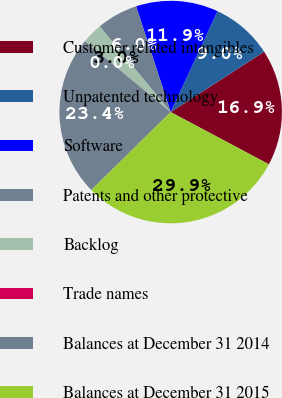<chart> <loc_0><loc_0><loc_500><loc_500><pie_chart><fcel>Customer related intangibles<fcel>Unpatented technology<fcel>Software<fcel>Patents and other protective<fcel>Backlog<fcel>Trade names<fcel>Balances at December 31 2014<fcel>Balances at December 31 2015<nl><fcel>16.9%<fcel>8.96%<fcel>11.95%<fcel>5.98%<fcel>2.99%<fcel>0.01%<fcel>23.36%<fcel>29.86%<nl></chart> 